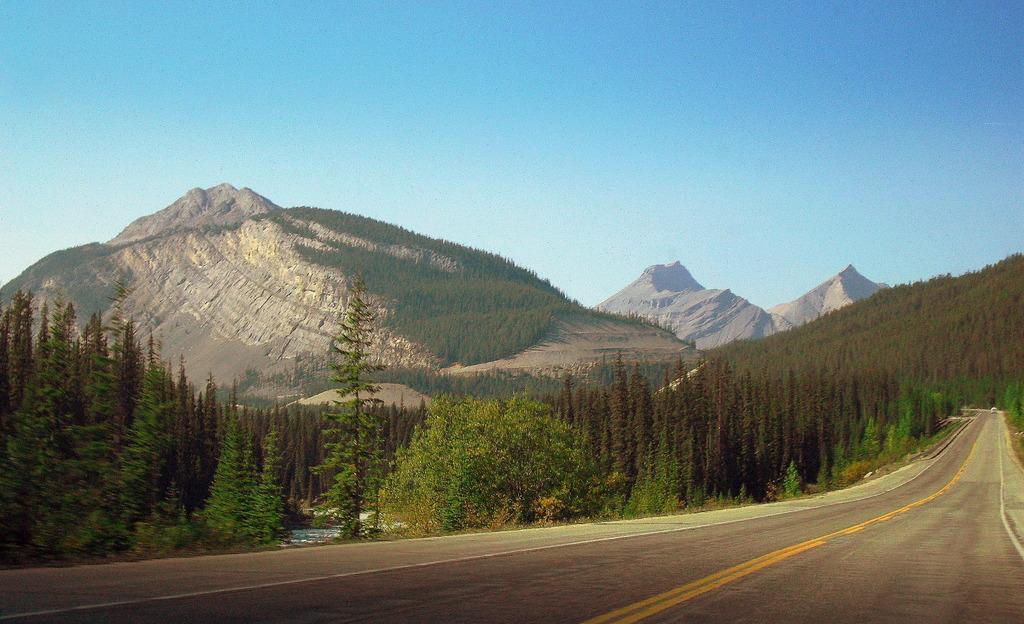How would you summarize this image in a sentence or two? In this image we can see a vehicle on the pathway. We can also see a group of trees, the hills and the sky which looks cloudy. 